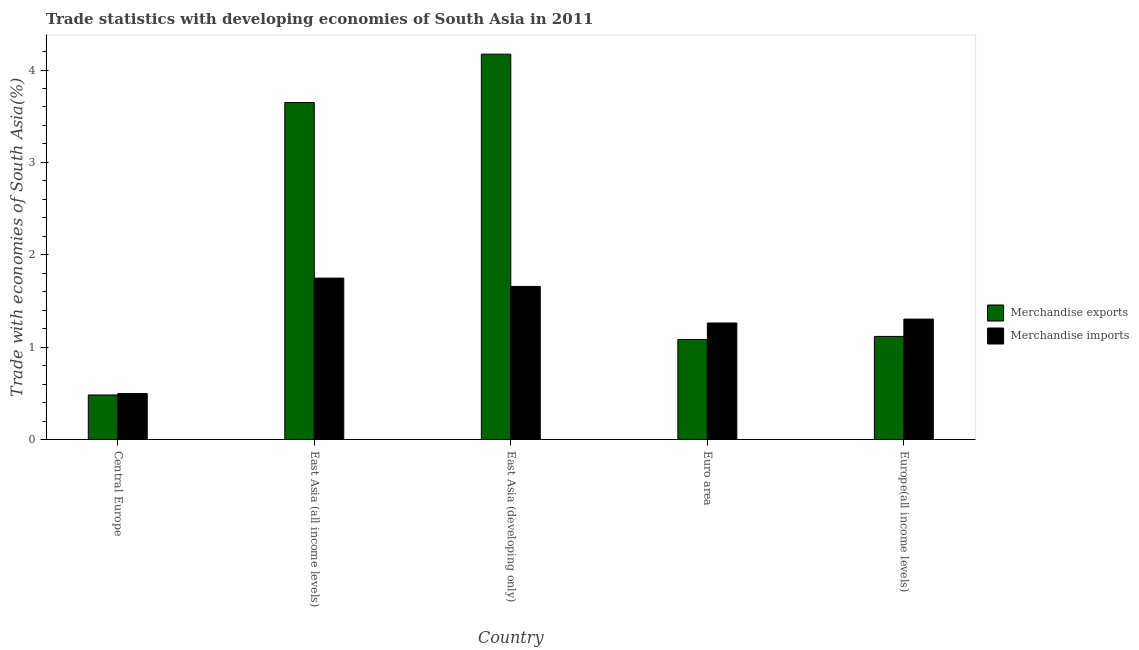How many groups of bars are there?
Keep it short and to the point. 5. Are the number of bars per tick equal to the number of legend labels?
Offer a very short reply. Yes. Are the number of bars on each tick of the X-axis equal?
Your answer should be very brief. Yes. How many bars are there on the 1st tick from the left?
Ensure brevity in your answer.  2. How many bars are there on the 1st tick from the right?
Ensure brevity in your answer.  2. What is the label of the 4th group of bars from the left?
Provide a succinct answer. Euro area. In how many cases, is the number of bars for a given country not equal to the number of legend labels?
Offer a terse response. 0. What is the merchandise exports in Euro area?
Offer a terse response. 1.08. Across all countries, what is the maximum merchandise imports?
Keep it short and to the point. 1.75. Across all countries, what is the minimum merchandise exports?
Make the answer very short. 0.48. In which country was the merchandise exports maximum?
Ensure brevity in your answer.  East Asia (developing only). In which country was the merchandise imports minimum?
Make the answer very short. Central Europe. What is the total merchandise imports in the graph?
Provide a short and direct response. 6.47. What is the difference between the merchandise imports in East Asia (all income levels) and that in Euro area?
Your answer should be compact. 0.49. What is the difference between the merchandise imports in East Asia (developing only) and the merchandise exports in Central Europe?
Offer a very short reply. 1.17. What is the average merchandise exports per country?
Give a very brief answer. 2.1. What is the difference between the merchandise exports and merchandise imports in East Asia (all income levels)?
Provide a succinct answer. 1.9. What is the ratio of the merchandise exports in Central Europe to that in Europe(all income levels)?
Provide a short and direct response. 0.43. Is the difference between the merchandise exports in Central Europe and East Asia (all income levels) greater than the difference between the merchandise imports in Central Europe and East Asia (all income levels)?
Your response must be concise. No. What is the difference between the highest and the second highest merchandise imports?
Your answer should be compact. 0.09. What is the difference between the highest and the lowest merchandise exports?
Keep it short and to the point. 3.69. In how many countries, is the merchandise exports greater than the average merchandise exports taken over all countries?
Your response must be concise. 2. How many countries are there in the graph?
Provide a succinct answer. 5. What is the difference between two consecutive major ticks on the Y-axis?
Keep it short and to the point. 1. Are the values on the major ticks of Y-axis written in scientific E-notation?
Ensure brevity in your answer.  No. How are the legend labels stacked?
Your answer should be very brief. Vertical. What is the title of the graph?
Make the answer very short. Trade statistics with developing economies of South Asia in 2011. Does "Formally registered" appear as one of the legend labels in the graph?
Provide a succinct answer. No. What is the label or title of the Y-axis?
Your response must be concise. Trade with economies of South Asia(%). What is the Trade with economies of South Asia(%) in Merchandise exports in Central Europe?
Make the answer very short. 0.48. What is the Trade with economies of South Asia(%) of Merchandise imports in Central Europe?
Keep it short and to the point. 0.5. What is the Trade with economies of South Asia(%) of Merchandise exports in East Asia (all income levels)?
Keep it short and to the point. 3.65. What is the Trade with economies of South Asia(%) in Merchandise imports in East Asia (all income levels)?
Give a very brief answer. 1.75. What is the Trade with economies of South Asia(%) in Merchandise exports in East Asia (developing only)?
Make the answer very short. 4.17. What is the Trade with economies of South Asia(%) of Merchandise imports in East Asia (developing only)?
Ensure brevity in your answer.  1.66. What is the Trade with economies of South Asia(%) in Merchandise exports in Euro area?
Offer a very short reply. 1.08. What is the Trade with economies of South Asia(%) in Merchandise imports in Euro area?
Your response must be concise. 1.26. What is the Trade with economies of South Asia(%) in Merchandise exports in Europe(all income levels)?
Keep it short and to the point. 1.12. What is the Trade with economies of South Asia(%) in Merchandise imports in Europe(all income levels)?
Provide a succinct answer. 1.3. Across all countries, what is the maximum Trade with economies of South Asia(%) in Merchandise exports?
Your answer should be very brief. 4.17. Across all countries, what is the maximum Trade with economies of South Asia(%) of Merchandise imports?
Your answer should be compact. 1.75. Across all countries, what is the minimum Trade with economies of South Asia(%) in Merchandise exports?
Make the answer very short. 0.48. Across all countries, what is the minimum Trade with economies of South Asia(%) of Merchandise imports?
Provide a short and direct response. 0.5. What is the total Trade with economies of South Asia(%) of Merchandise exports in the graph?
Your response must be concise. 10.5. What is the total Trade with economies of South Asia(%) in Merchandise imports in the graph?
Your answer should be compact. 6.47. What is the difference between the Trade with economies of South Asia(%) of Merchandise exports in Central Europe and that in East Asia (all income levels)?
Provide a succinct answer. -3.17. What is the difference between the Trade with economies of South Asia(%) in Merchandise imports in Central Europe and that in East Asia (all income levels)?
Offer a very short reply. -1.25. What is the difference between the Trade with economies of South Asia(%) in Merchandise exports in Central Europe and that in East Asia (developing only)?
Make the answer very short. -3.69. What is the difference between the Trade with economies of South Asia(%) in Merchandise imports in Central Europe and that in East Asia (developing only)?
Provide a short and direct response. -1.16. What is the difference between the Trade with economies of South Asia(%) of Merchandise exports in Central Europe and that in Euro area?
Provide a short and direct response. -0.6. What is the difference between the Trade with economies of South Asia(%) in Merchandise imports in Central Europe and that in Euro area?
Offer a very short reply. -0.76. What is the difference between the Trade with economies of South Asia(%) of Merchandise exports in Central Europe and that in Europe(all income levels)?
Provide a succinct answer. -0.63. What is the difference between the Trade with economies of South Asia(%) of Merchandise imports in Central Europe and that in Europe(all income levels)?
Ensure brevity in your answer.  -0.81. What is the difference between the Trade with economies of South Asia(%) in Merchandise exports in East Asia (all income levels) and that in East Asia (developing only)?
Your answer should be compact. -0.52. What is the difference between the Trade with economies of South Asia(%) of Merchandise imports in East Asia (all income levels) and that in East Asia (developing only)?
Make the answer very short. 0.09. What is the difference between the Trade with economies of South Asia(%) in Merchandise exports in East Asia (all income levels) and that in Euro area?
Offer a terse response. 2.57. What is the difference between the Trade with economies of South Asia(%) in Merchandise imports in East Asia (all income levels) and that in Euro area?
Provide a succinct answer. 0.49. What is the difference between the Trade with economies of South Asia(%) in Merchandise exports in East Asia (all income levels) and that in Europe(all income levels)?
Your answer should be compact. 2.53. What is the difference between the Trade with economies of South Asia(%) of Merchandise imports in East Asia (all income levels) and that in Europe(all income levels)?
Your answer should be compact. 0.44. What is the difference between the Trade with economies of South Asia(%) of Merchandise exports in East Asia (developing only) and that in Euro area?
Ensure brevity in your answer.  3.09. What is the difference between the Trade with economies of South Asia(%) of Merchandise imports in East Asia (developing only) and that in Euro area?
Your answer should be compact. 0.4. What is the difference between the Trade with economies of South Asia(%) of Merchandise exports in East Asia (developing only) and that in Europe(all income levels)?
Ensure brevity in your answer.  3.06. What is the difference between the Trade with economies of South Asia(%) in Merchandise imports in East Asia (developing only) and that in Europe(all income levels)?
Give a very brief answer. 0.35. What is the difference between the Trade with economies of South Asia(%) in Merchandise exports in Euro area and that in Europe(all income levels)?
Your answer should be compact. -0.03. What is the difference between the Trade with economies of South Asia(%) in Merchandise imports in Euro area and that in Europe(all income levels)?
Offer a very short reply. -0.04. What is the difference between the Trade with economies of South Asia(%) in Merchandise exports in Central Europe and the Trade with economies of South Asia(%) in Merchandise imports in East Asia (all income levels)?
Make the answer very short. -1.26. What is the difference between the Trade with economies of South Asia(%) of Merchandise exports in Central Europe and the Trade with economies of South Asia(%) of Merchandise imports in East Asia (developing only)?
Offer a terse response. -1.17. What is the difference between the Trade with economies of South Asia(%) of Merchandise exports in Central Europe and the Trade with economies of South Asia(%) of Merchandise imports in Euro area?
Keep it short and to the point. -0.78. What is the difference between the Trade with economies of South Asia(%) in Merchandise exports in Central Europe and the Trade with economies of South Asia(%) in Merchandise imports in Europe(all income levels)?
Ensure brevity in your answer.  -0.82. What is the difference between the Trade with economies of South Asia(%) in Merchandise exports in East Asia (all income levels) and the Trade with economies of South Asia(%) in Merchandise imports in East Asia (developing only)?
Keep it short and to the point. 1.99. What is the difference between the Trade with economies of South Asia(%) in Merchandise exports in East Asia (all income levels) and the Trade with economies of South Asia(%) in Merchandise imports in Euro area?
Your answer should be very brief. 2.39. What is the difference between the Trade with economies of South Asia(%) of Merchandise exports in East Asia (all income levels) and the Trade with economies of South Asia(%) of Merchandise imports in Europe(all income levels)?
Provide a succinct answer. 2.34. What is the difference between the Trade with economies of South Asia(%) in Merchandise exports in East Asia (developing only) and the Trade with economies of South Asia(%) in Merchandise imports in Euro area?
Your answer should be very brief. 2.91. What is the difference between the Trade with economies of South Asia(%) of Merchandise exports in East Asia (developing only) and the Trade with economies of South Asia(%) of Merchandise imports in Europe(all income levels)?
Ensure brevity in your answer.  2.87. What is the difference between the Trade with economies of South Asia(%) of Merchandise exports in Euro area and the Trade with economies of South Asia(%) of Merchandise imports in Europe(all income levels)?
Ensure brevity in your answer.  -0.22. What is the average Trade with economies of South Asia(%) of Merchandise exports per country?
Provide a short and direct response. 2.1. What is the average Trade with economies of South Asia(%) in Merchandise imports per country?
Offer a terse response. 1.29. What is the difference between the Trade with economies of South Asia(%) of Merchandise exports and Trade with economies of South Asia(%) of Merchandise imports in Central Europe?
Offer a very short reply. -0.01. What is the difference between the Trade with economies of South Asia(%) of Merchandise exports and Trade with economies of South Asia(%) of Merchandise imports in East Asia (all income levels)?
Offer a terse response. 1.9. What is the difference between the Trade with economies of South Asia(%) of Merchandise exports and Trade with economies of South Asia(%) of Merchandise imports in East Asia (developing only)?
Offer a terse response. 2.51. What is the difference between the Trade with economies of South Asia(%) of Merchandise exports and Trade with economies of South Asia(%) of Merchandise imports in Euro area?
Make the answer very short. -0.18. What is the difference between the Trade with economies of South Asia(%) in Merchandise exports and Trade with economies of South Asia(%) in Merchandise imports in Europe(all income levels)?
Offer a very short reply. -0.19. What is the ratio of the Trade with economies of South Asia(%) in Merchandise exports in Central Europe to that in East Asia (all income levels)?
Ensure brevity in your answer.  0.13. What is the ratio of the Trade with economies of South Asia(%) of Merchandise imports in Central Europe to that in East Asia (all income levels)?
Make the answer very short. 0.28. What is the ratio of the Trade with economies of South Asia(%) in Merchandise exports in Central Europe to that in East Asia (developing only)?
Your answer should be very brief. 0.12. What is the ratio of the Trade with economies of South Asia(%) in Merchandise exports in Central Europe to that in Euro area?
Make the answer very short. 0.45. What is the ratio of the Trade with economies of South Asia(%) in Merchandise imports in Central Europe to that in Euro area?
Offer a very short reply. 0.39. What is the ratio of the Trade with economies of South Asia(%) of Merchandise exports in Central Europe to that in Europe(all income levels)?
Provide a short and direct response. 0.43. What is the ratio of the Trade with economies of South Asia(%) of Merchandise imports in Central Europe to that in Europe(all income levels)?
Ensure brevity in your answer.  0.38. What is the ratio of the Trade with economies of South Asia(%) in Merchandise exports in East Asia (all income levels) to that in East Asia (developing only)?
Provide a short and direct response. 0.87. What is the ratio of the Trade with economies of South Asia(%) in Merchandise imports in East Asia (all income levels) to that in East Asia (developing only)?
Provide a short and direct response. 1.05. What is the ratio of the Trade with economies of South Asia(%) of Merchandise exports in East Asia (all income levels) to that in Euro area?
Your answer should be very brief. 3.37. What is the ratio of the Trade with economies of South Asia(%) in Merchandise imports in East Asia (all income levels) to that in Euro area?
Offer a very short reply. 1.39. What is the ratio of the Trade with economies of South Asia(%) in Merchandise exports in East Asia (all income levels) to that in Europe(all income levels)?
Your answer should be very brief. 3.27. What is the ratio of the Trade with economies of South Asia(%) of Merchandise imports in East Asia (all income levels) to that in Europe(all income levels)?
Offer a terse response. 1.34. What is the ratio of the Trade with economies of South Asia(%) of Merchandise exports in East Asia (developing only) to that in Euro area?
Give a very brief answer. 3.85. What is the ratio of the Trade with economies of South Asia(%) in Merchandise imports in East Asia (developing only) to that in Euro area?
Give a very brief answer. 1.31. What is the ratio of the Trade with economies of South Asia(%) of Merchandise exports in East Asia (developing only) to that in Europe(all income levels)?
Offer a terse response. 3.74. What is the ratio of the Trade with economies of South Asia(%) of Merchandise imports in East Asia (developing only) to that in Europe(all income levels)?
Offer a very short reply. 1.27. What is the ratio of the Trade with economies of South Asia(%) in Merchandise exports in Euro area to that in Europe(all income levels)?
Provide a succinct answer. 0.97. What is the ratio of the Trade with economies of South Asia(%) of Merchandise imports in Euro area to that in Europe(all income levels)?
Provide a short and direct response. 0.97. What is the difference between the highest and the second highest Trade with economies of South Asia(%) of Merchandise exports?
Provide a succinct answer. 0.52. What is the difference between the highest and the second highest Trade with economies of South Asia(%) of Merchandise imports?
Provide a succinct answer. 0.09. What is the difference between the highest and the lowest Trade with economies of South Asia(%) in Merchandise exports?
Your response must be concise. 3.69. 